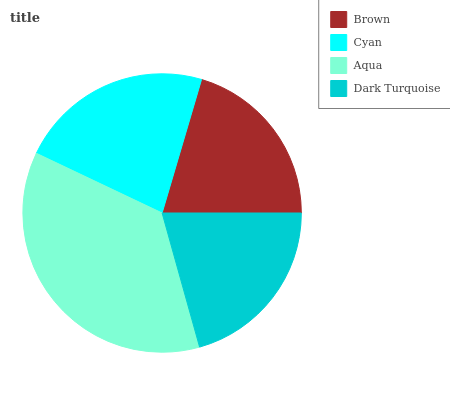Is Brown the minimum?
Answer yes or no. Yes. Is Aqua the maximum?
Answer yes or no. Yes. Is Cyan the minimum?
Answer yes or no. No. Is Cyan the maximum?
Answer yes or no. No. Is Cyan greater than Brown?
Answer yes or no. Yes. Is Brown less than Cyan?
Answer yes or no. Yes. Is Brown greater than Cyan?
Answer yes or no. No. Is Cyan less than Brown?
Answer yes or no. No. Is Cyan the high median?
Answer yes or no. Yes. Is Dark Turquoise the low median?
Answer yes or no. Yes. Is Dark Turquoise the high median?
Answer yes or no. No. Is Brown the low median?
Answer yes or no. No. 